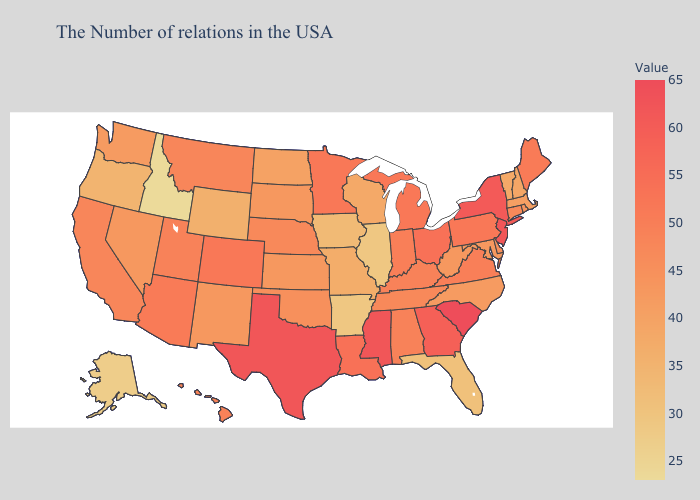Which states have the highest value in the USA?
Write a very short answer. South Carolina. Does Arkansas have the lowest value in the South?
Answer briefly. Yes. Does Illinois have the lowest value in the MidWest?
Short answer required. Yes. Among the states that border North Carolina , which have the highest value?
Keep it brief. South Carolina. Among the states that border Arizona , which have the highest value?
Write a very short answer. Colorado. 